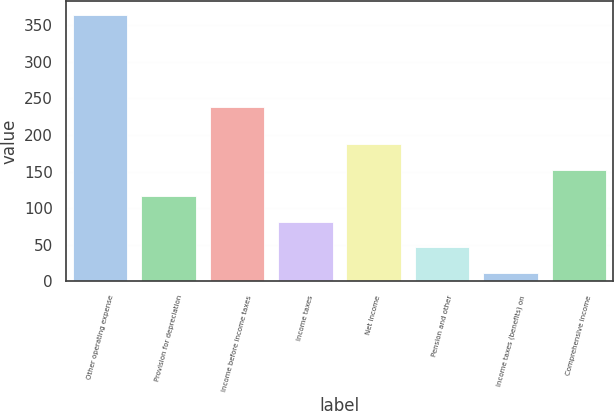Convert chart to OTSL. <chart><loc_0><loc_0><loc_500><loc_500><bar_chart><fcel>Other operating expense<fcel>Provision for depreciation<fcel>Income before income taxes<fcel>Income taxes<fcel>Net Income<fcel>Pension and other<fcel>Income taxes (benefits) on<fcel>Comprehensive income<nl><fcel>364<fcel>116.9<fcel>238<fcel>81.6<fcel>187.5<fcel>46.3<fcel>11<fcel>152.2<nl></chart> 